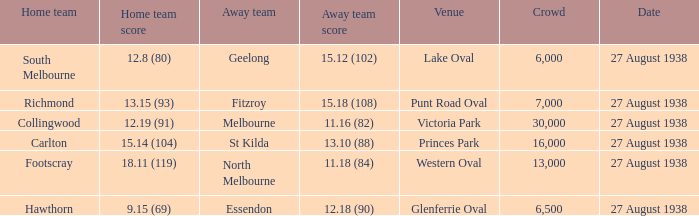Which Team plays at Western Oval? Footscray. 